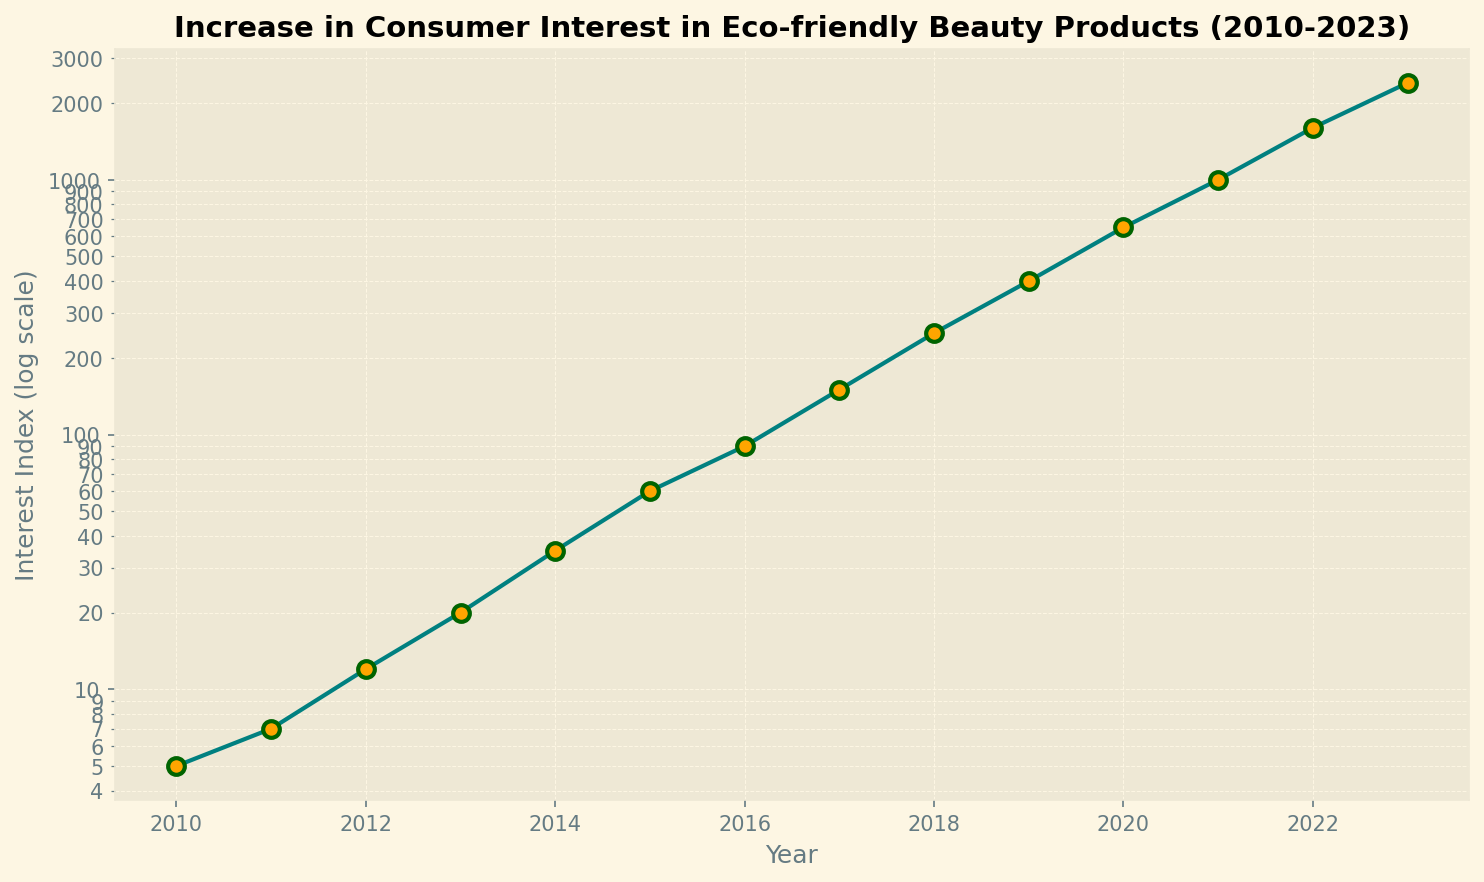Which year shows the highest increase in consumer interest in eco-friendly beauty products? The year 2023 has the highest Interest Index. From the plot, it is evident that 2023 marks the peak of consumer interest, reaching 2400.
Answer: 2023 What is the percentage increase in the Interest Index from 2010 to 2023? The Interest Index in 2010 is 5 and in 2023 it is 2400. Calculating the percentage increase: ((2400 - 5) / 5) * 100 = 47900%.
Answer: 47900% How does the Interest Index in 2017 compare to that in 2014? The Interest Index in 2017 is 150, while it is 35 in 2014. Comparing the two: 150 is greater than 35.
Answer: 150 > 35 What is the median Interest Index over the entire period? To find the median, we need to order the Interest Index values and find the middle one. The ordered Interest Index values are: 5, 7, 12, 20, 35, 60, 90, 150, 250, 400, 650, 1000, 1600, 2400. The median value (7th and 8th in a list of 14) is the average of 90 and 150, which is (90 + 150)/2 = 120.
Answer: 120 From which year did the Interest Index start rising exponentially? Observing the plot, the exponential rise appears to commence around 2015. From 2014 to 2015, the Interest Index jumped from 35 to 60, then continued rising sharply.
Answer: 2015 What can you say about the trend in the Interest Index in eco-friendly beauty products from 2010 to 2023? The trend shows an exponential increase in consumer interest from 2010 to 2023, with the Interest Index rising from 5 to 2400 over this period.
Answer: Exponential increase How many times greater is the Interest Index in 2023 compared to 2010? The Interest Index in 2023 is 2400 and in 2010 it is 5. The ratio is 2400/5 = 480 times.
Answer: 480 times What are the visual differences in the plot markers for the data points? The markers on the plot are circular, orange in color with a dark green edge, and have a notable size, making them clearly visible against the teal line.
Answer: Circular, orange with dark green edge 